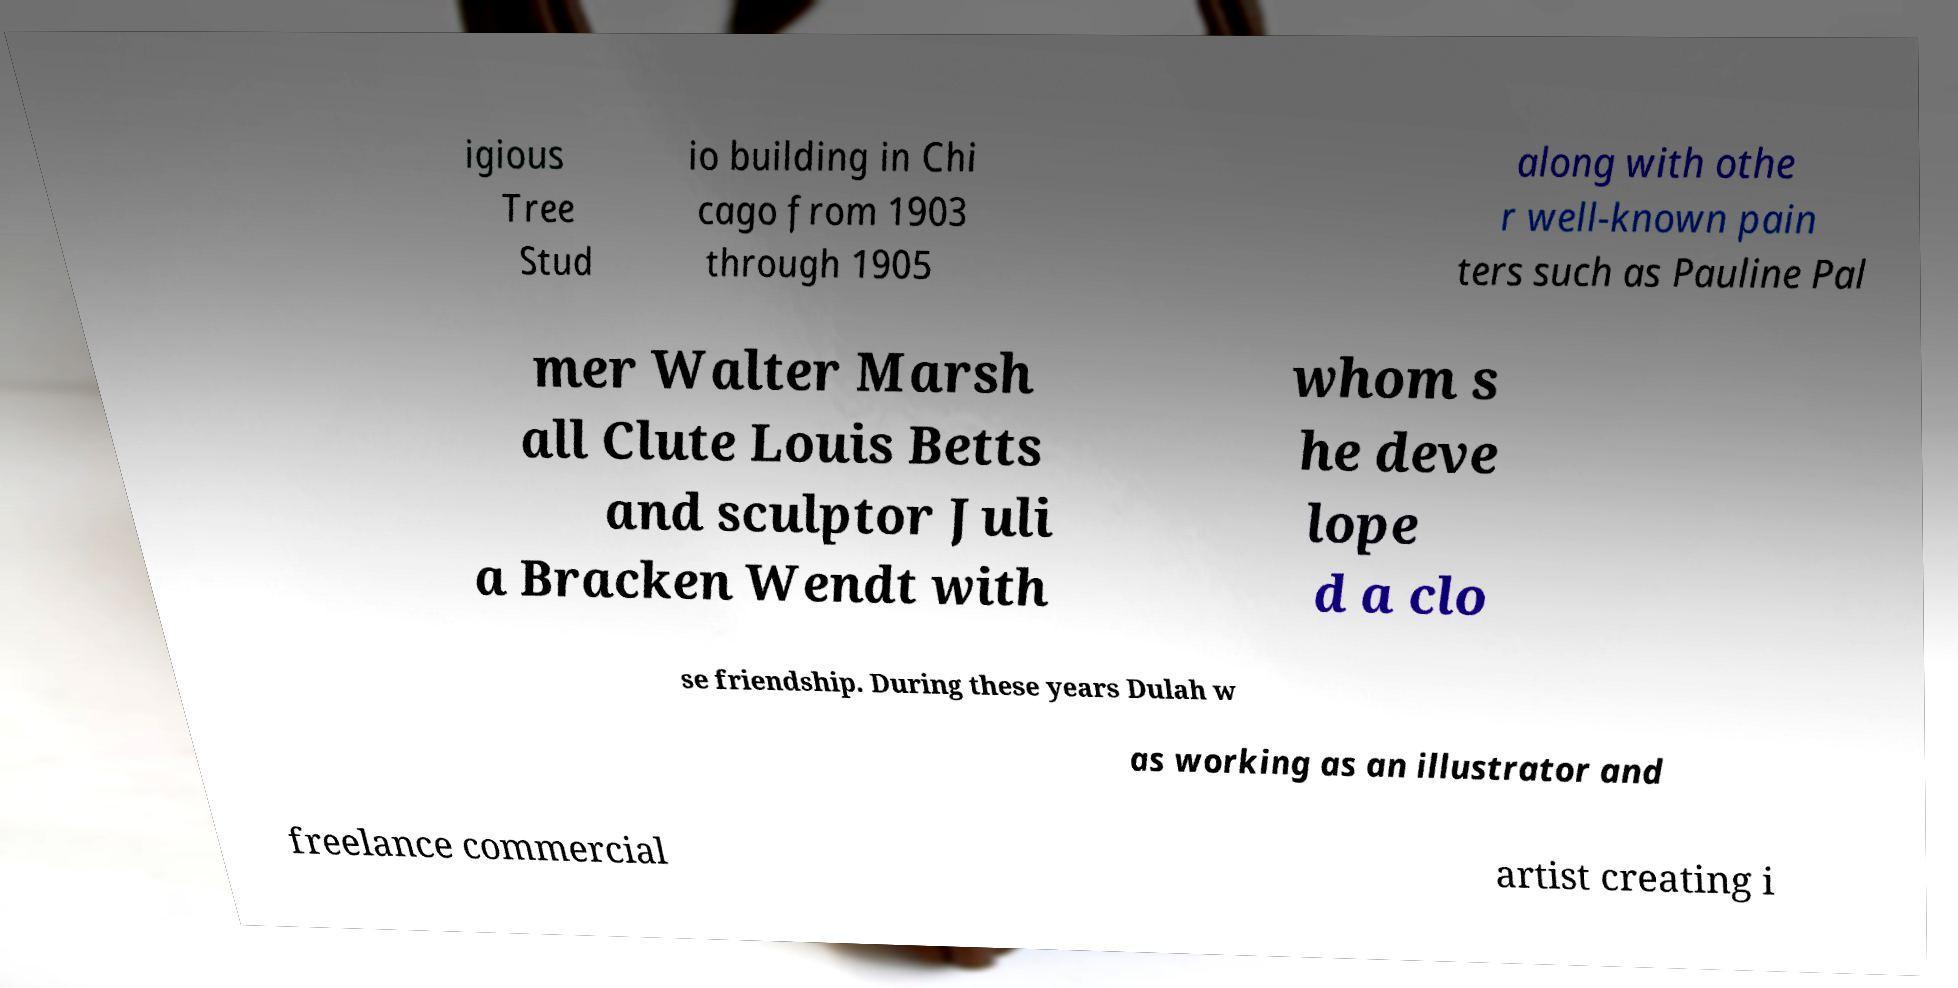I need the written content from this picture converted into text. Can you do that? igious Tree Stud io building in Chi cago from 1903 through 1905 along with othe r well-known pain ters such as Pauline Pal mer Walter Marsh all Clute Louis Betts and sculptor Juli a Bracken Wendt with whom s he deve lope d a clo se friendship. During these years Dulah w as working as an illustrator and freelance commercial artist creating i 